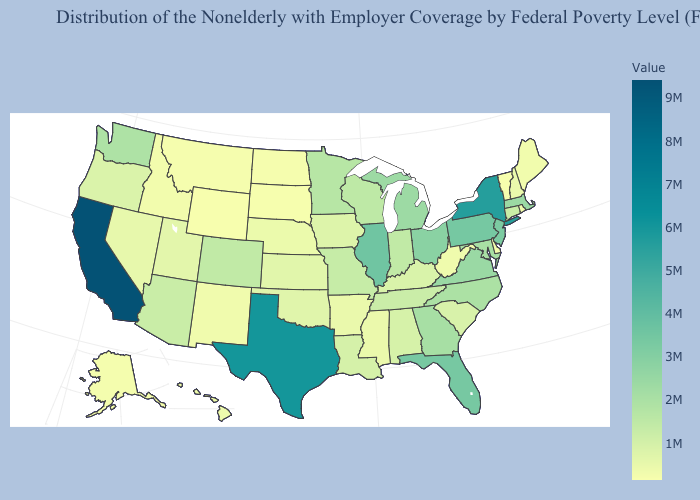Does the map have missing data?
Write a very short answer. No. Among the states that border New Hampshire , does Maine have the highest value?
Give a very brief answer. No. Does Tennessee have a lower value than Montana?
Quick response, please. No. Among the states that border North Carolina , does Georgia have the highest value?
Write a very short answer. No. Among the states that border Nevada , which have the lowest value?
Write a very short answer. Idaho. Which states have the highest value in the USA?
Give a very brief answer. California. Which states have the lowest value in the Northeast?
Concise answer only. Vermont. Which states have the lowest value in the MidWest?
Write a very short answer. South Dakota. Which states have the lowest value in the USA?
Keep it brief. Wyoming. 